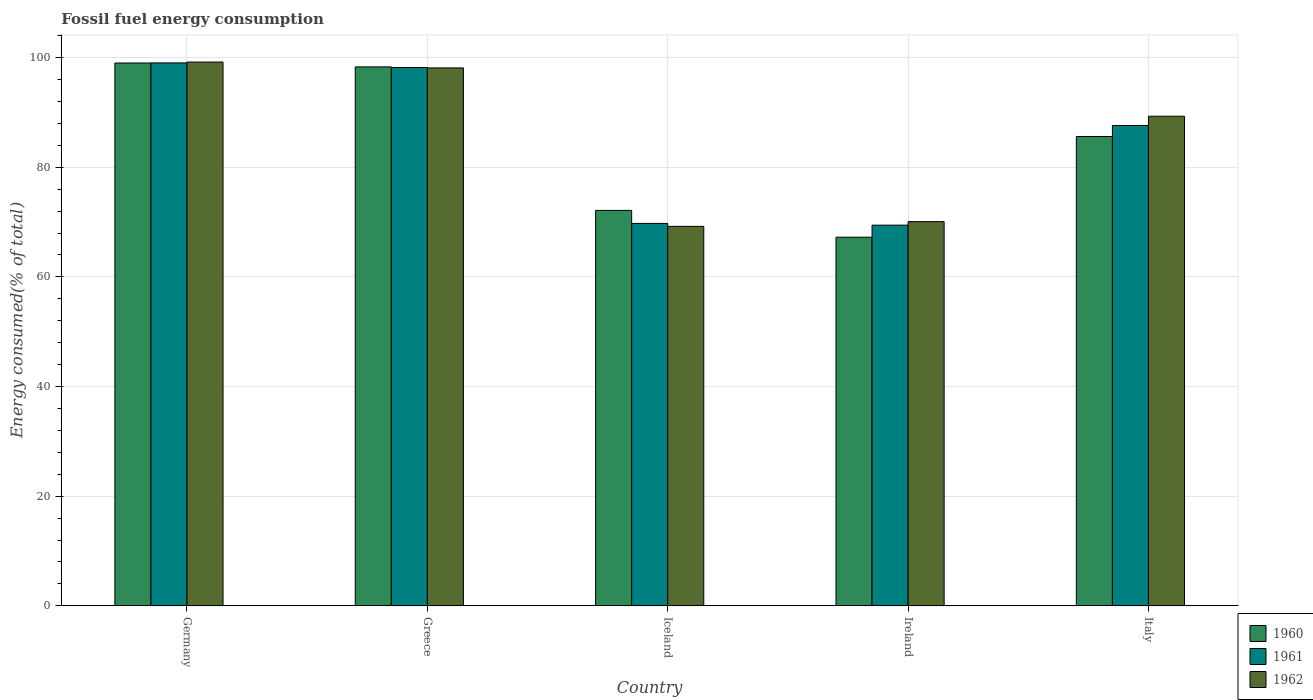How many different coloured bars are there?
Provide a succinct answer. 3. How many groups of bars are there?
Provide a short and direct response. 5. Are the number of bars per tick equal to the number of legend labels?
Ensure brevity in your answer.  Yes. What is the label of the 4th group of bars from the left?
Provide a succinct answer. Ireland. What is the percentage of energy consumed in 1962 in Iceland?
Make the answer very short. 69.22. Across all countries, what is the maximum percentage of energy consumed in 1962?
Your response must be concise. 99.19. Across all countries, what is the minimum percentage of energy consumed in 1961?
Ensure brevity in your answer.  69.44. In which country was the percentage of energy consumed in 1962 maximum?
Your answer should be compact. Germany. In which country was the percentage of energy consumed in 1961 minimum?
Make the answer very short. Ireland. What is the total percentage of energy consumed in 1962 in the graph?
Your answer should be compact. 425.93. What is the difference between the percentage of energy consumed in 1960 in Greece and that in Ireland?
Keep it short and to the point. 31.07. What is the difference between the percentage of energy consumed in 1961 in Greece and the percentage of energy consumed in 1960 in Ireland?
Your response must be concise. 30.96. What is the average percentage of energy consumed in 1961 per country?
Keep it short and to the point. 84.81. What is the difference between the percentage of energy consumed of/in 1961 and percentage of energy consumed of/in 1960 in Greece?
Give a very brief answer. -0.11. What is the ratio of the percentage of energy consumed in 1960 in Greece to that in Iceland?
Your response must be concise. 1.36. Is the percentage of energy consumed in 1961 in Iceland less than that in Ireland?
Your response must be concise. No. What is the difference between the highest and the second highest percentage of energy consumed in 1961?
Offer a very short reply. -0.84. What is the difference between the highest and the lowest percentage of energy consumed in 1962?
Offer a terse response. 29.98. What does the 1st bar from the left in Germany represents?
Make the answer very short. 1960. What does the 2nd bar from the right in Iceland represents?
Your answer should be compact. 1961. How many bars are there?
Your response must be concise. 15. Are all the bars in the graph horizontal?
Your answer should be compact. No. Are the values on the major ticks of Y-axis written in scientific E-notation?
Keep it short and to the point. No. Does the graph contain any zero values?
Provide a short and direct response. No. Where does the legend appear in the graph?
Give a very brief answer. Bottom right. How many legend labels are there?
Your response must be concise. 3. What is the title of the graph?
Provide a succinct answer. Fossil fuel energy consumption. Does "1963" appear as one of the legend labels in the graph?
Keep it short and to the point. No. What is the label or title of the X-axis?
Give a very brief answer. Country. What is the label or title of the Y-axis?
Ensure brevity in your answer.  Energy consumed(% of total). What is the Energy consumed(% of total) in 1960 in Germany?
Your response must be concise. 99.02. What is the Energy consumed(% of total) in 1961 in Germany?
Your answer should be very brief. 99.04. What is the Energy consumed(% of total) in 1962 in Germany?
Your response must be concise. 99.19. What is the Energy consumed(% of total) of 1960 in Greece?
Your answer should be compact. 98.31. What is the Energy consumed(% of total) of 1961 in Greece?
Keep it short and to the point. 98.2. What is the Energy consumed(% of total) of 1962 in Greece?
Provide a short and direct response. 98.12. What is the Energy consumed(% of total) of 1960 in Iceland?
Provide a short and direct response. 72.13. What is the Energy consumed(% of total) of 1961 in Iceland?
Your answer should be compact. 69.76. What is the Energy consumed(% of total) in 1962 in Iceland?
Offer a very short reply. 69.22. What is the Energy consumed(% of total) of 1960 in Ireland?
Provide a short and direct response. 67.24. What is the Energy consumed(% of total) in 1961 in Ireland?
Give a very brief answer. 69.44. What is the Energy consumed(% of total) of 1962 in Ireland?
Make the answer very short. 70.09. What is the Energy consumed(% of total) of 1960 in Italy?
Your answer should be compact. 85.61. What is the Energy consumed(% of total) in 1961 in Italy?
Give a very brief answer. 87.62. What is the Energy consumed(% of total) in 1962 in Italy?
Keep it short and to the point. 89.31. Across all countries, what is the maximum Energy consumed(% of total) in 1960?
Your response must be concise. 99.02. Across all countries, what is the maximum Energy consumed(% of total) in 1961?
Offer a very short reply. 99.04. Across all countries, what is the maximum Energy consumed(% of total) in 1962?
Ensure brevity in your answer.  99.19. Across all countries, what is the minimum Energy consumed(% of total) in 1960?
Give a very brief answer. 67.24. Across all countries, what is the minimum Energy consumed(% of total) of 1961?
Make the answer very short. 69.44. Across all countries, what is the minimum Energy consumed(% of total) of 1962?
Your answer should be compact. 69.22. What is the total Energy consumed(% of total) in 1960 in the graph?
Make the answer very short. 422.31. What is the total Energy consumed(% of total) in 1961 in the graph?
Provide a short and direct response. 424.05. What is the total Energy consumed(% of total) of 1962 in the graph?
Offer a terse response. 425.93. What is the difference between the Energy consumed(% of total) in 1960 in Germany and that in Greece?
Offer a terse response. 0.71. What is the difference between the Energy consumed(% of total) of 1961 in Germany and that in Greece?
Ensure brevity in your answer.  0.84. What is the difference between the Energy consumed(% of total) of 1962 in Germany and that in Greece?
Make the answer very short. 1.07. What is the difference between the Energy consumed(% of total) of 1960 in Germany and that in Iceland?
Ensure brevity in your answer.  26.89. What is the difference between the Energy consumed(% of total) of 1961 in Germany and that in Iceland?
Give a very brief answer. 29.28. What is the difference between the Energy consumed(% of total) of 1962 in Germany and that in Iceland?
Give a very brief answer. 29.98. What is the difference between the Energy consumed(% of total) in 1960 in Germany and that in Ireland?
Give a very brief answer. 31.78. What is the difference between the Energy consumed(% of total) of 1961 in Germany and that in Ireland?
Your response must be concise. 29.6. What is the difference between the Energy consumed(% of total) in 1962 in Germany and that in Ireland?
Your answer should be compact. 29.11. What is the difference between the Energy consumed(% of total) in 1960 in Germany and that in Italy?
Provide a short and direct response. 13.41. What is the difference between the Energy consumed(% of total) in 1961 in Germany and that in Italy?
Give a very brief answer. 11.42. What is the difference between the Energy consumed(% of total) in 1962 in Germany and that in Italy?
Make the answer very short. 9.88. What is the difference between the Energy consumed(% of total) in 1960 in Greece and that in Iceland?
Your answer should be very brief. 26.18. What is the difference between the Energy consumed(% of total) in 1961 in Greece and that in Iceland?
Offer a very short reply. 28.44. What is the difference between the Energy consumed(% of total) of 1962 in Greece and that in Iceland?
Your answer should be very brief. 28.91. What is the difference between the Energy consumed(% of total) in 1960 in Greece and that in Ireland?
Ensure brevity in your answer.  31.07. What is the difference between the Energy consumed(% of total) of 1961 in Greece and that in Ireland?
Provide a succinct answer. 28.76. What is the difference between the Energy consumed(% of total) in 1962 in Greece and that in Ireland?
Make the answer very short. 28.04. What is the difference between the Energy consumed(% of total) of 1960 in Greece and that in Italy?
Make the answer very short. 12.7. What is the difference between the Energy consumed(% of total) in 1961 in Greece and that in Italy?
Your response must be concise. 10.58. What is the difference between the Energy consumed(% of total) in 1962 in Greece and that in Italy?
Offer a terse response. 8.81. What is the difference between the Energy consumed(% of total) in 1960 in Iceland and that in Ireland?
Ensure brevity in your answer.  4.89. What is the difference between the Energy consumed(% of total) of 1961 in Iceland and that in Ireland?
Offer a terse response. 0.32. What is the difference between the Energy consumed(% of total) in 1962 in Iceland and that in Ireland?
Give a very brief answer. -0.87. What is the difference between the Energy consumed(% of total) in 1960 in Iceland and that in Italy?
Make the answer very short. -13.48. What is the difference between the Energy consumed(% of total) in 1961 in Iceland and that in Italy?
Provide a short and direct response. -17.86. What is the difference between the Energy consumed(% of total) of 1962 in Iceland and that in Italy?
Offer a terse response. -20.09. What is the difference between the Energy consumed(% of total) in 1960 in Ireland and that in Italy?
Offer a very short reply. -18.37. What is the difference between the Energy consumed(% of total) of 1961 in Ireland and that in Italy?
Provide a succinct answer. -18.18. What is the difference between the Energy consumed(% of total) in 1962 in Ireland and that in Italy?
Your response must be concise. -19.23. What is the difference between the Energy consumed(% of total) in 1960 in Germany and the Energy consumed(% of total) in 1961 in Greece?
Ensure brevity in your answer.  0.82. What is the difference between the Energy consumed(% of total) of 1960 in Germany and the Energy consumed(% of total) of 1962 in Greece?
Offer a very short reply. 0.9. What is the difference between the Energy consumed(% of total) in 1961 in Germany and the Energy consumed(% of total) in 1962 in Greece?
Provide a short and direct response. 0.92. What is the difference between the Energy consumed(% of total) of 1960 in Germany and the Energy consumed(% of total) of 1961 in Iceland?
Your response must be concise. 29.26. What is the difference between the Energy consumed(% of total) in 1960 in Germany and the Energy consumed(% of total) in 1962 in Iceland?
Offer a terse response. 29.8. What is the difference between the Energy consumed(% of total) in 1961 in Germany and the Energy consumed(% of total) in 1962 in Iceland?
Provide a succinct answer. 29.82. What is the difference between the Energy consumed(% of total) in 1960 in Germany and the Energy consumed(% of total) in 1961 in Ireland?
Make the answer very short. 29.58. What is the difference between the Energy consumed(% of total) in 1960 in Germany and the Energy consumed(% of total) in 1962 in Ireland?
Ensure brevity in your answer.  28.93. What is the difference between the Energy consumed(% of total) of 1961 in Germany and the Energy consumed(% of total) of 1962 in Ireland?
Provide a short and direct response. 28.96. What is the difference between the Energy consumed(% of total) of 1960 in Germany and the Energy consumed(% of total) of 1961 in Italy?
Keep it short and to the point. 11.4. What is the difference between the Energy consumed(% of total) in 1960 in Germany and the Energy consumed(% of total) in 1962 in Italy?
Your response must be concise. 9.71. What is the difference between the Energy consumed(% of total) in 1961 in Germany and the Energy consumed(% of total) in 1962 in Italy?
Offer a very short reply. 9.73. What is the difference between the Energy consumed(% of total) of 1960 in Greece and the Energy consumed(% of total) of 1961 in Iceland?
Ensure brevity in your answer.  28.55. What is the difference between the Energy consumed(% of total) of 1960 in Greece and the Energy consumed(% of total) of 1962 in Iceland?
Your answer should be very brief. 29.09. What is the difference between the Energy consumed(% of total) in 1961 in Greece and the Energy consumed(% of total) in 1962 in Iceland?
Provide a short and direct response. 28.98. What is the difference between the Energy consumed(% of total) of 1960 in Greece and the Energy consumed(% of total) of 1961 in Ireland?
Provide a succinct answer. 28.87. What is the difference between the Energy consumed(% of total) of 1960 in Greece and the Energy consumed(% of total) of 1962 in Ireland?
Your answer should be compact. 28.23. What is the difference between the Energy consumed(% of total) of 1961 in Greece and the Energy consumed(% of total) of 1962 in Ireland?
Ensure brevity in your answer.  28.11. What is the difference between the Energy consumed(% of total) in 1960 in Greece and the Energy consumed(% of total) in 1961 in Italy?
Your response must be concise. 10.69. What is the difference between the Energy consumed(% of total) of 1960 in Greece and the Energy consumed(% of total) of 1962 in Italy?
Your answer should be very brief. 9. What is the difference between the Energy consumed(% of total) in 1961 in Greece and the Energy consumed(% of total) in 1962 in Italy?
Offer a terse response. 8.89. What is the difference between the Energy consumed(% of total) of 1960 in Iceland and the Energy consumed(% of total) of 1961 in Ireland?
Make the answer very short. 2.69. What is the difference between the Energy consumed(% of total) in 1960 in Iceland and the Energy consumed(% of total) in 1962 in Ireland?
Offer a very short reply. 2.04. What is the difference between the Energy consumed(% of total) in 1961 in Iceland and the Energy consumed(% of total) in 1962 in Ireland?
Make the answer very short. -0.33. What is the difference between the Energy consumed(% of total) of 1960 in Iceland and the Energy consumed(% of total) of 1961 in Italy?
Offer a terse response. -15.49. What is the difference between the Energy consumed(% of total) in 1960 in Iceland and the Energy consumed(% of total) in 1962 in Italy?
Your response must be concise. -17.18. What is the difference between the Energy consumed(% of total) of 1961 in Iceland and the Energy consumed(% of total) of 1962 in Italy?
Offer a terse response. -19.55. What is the difference between the Energy consumed(% of total) in 1960 in Ireland and the Energy consumed(% of total) in 1961 in Italy?
Your response must be concise. -20.38. What is the difference between the Energy consumed(% of total) in 1960 in Ireland and the Energy consumed(% of total) in 1962 in Italy?
Your answer should be compact. -22.07. What is the difference between the Energy consumed(% of total) in 1961 in Ireland and the Energy consumed(% of total) in 1962 in Italy?
Ensure brevity in your answer.  -19.87. What is the average Energy consumed(% of total) in 1960 per country?
Provide a succinct answer. 84.46. What is the average Energy consumed(% of total) in 1961 per country?
Make the answer very short. 84.81. What is the average Energy consumed(% of total) in 1962 per country?
Make the answer very short. 85.19. What is the difference between the Energy consumed(% of total) of 1960 and Energy consumed(% of total) of 1961 in Germany?
Offer a terse response. -0.02. What is the difference between the Energy consumed(% of total) of 1960 and Energy consumed(% of total) of 1962 in Germany?
Provide a succinct answer. -0.17. What is the difference between the Energy consumed(% of total) in 1961 and Energy consumed(% of total) in 1962 in Germany?
Offer a terse response. -0.15. What is the difference between the Energy consumed(% of total) in 1960 and Energy consumed(% of total) in 1961 in Greece?
Keep it short and to the point. 0.11. What is the difference between the Energy consumed(% of total) in 1960 and Energy consumed(% of total) in 1962 in Greece?
Make the answer very short. 0.19. What is the difference between the Energy consumed(% of total) in 1961 and Energy consumed(% of total) in 1962 in Greece?
Keep it short and to the point. 0.07. What is the difference between the Energy consumed(% of total) of 1960 and Energy consumed(% of total) of 1961 in Iceland?
Make the answer very short. 2.37. What is the difference between the Energy consumed(% of total) in 1960 and Energy consumed(% of total) in 1962 in Iceland?
Your answer should be compact. 2.91. What is the difference between the Energy consumed(% of total) of 1961 and Energy consumed(% of total) of 1962 in Iceland?
Offer a very short reply. 0.54. What is the difference between the Energy consumed(% of total) of 1960 and Energy consumed(% of total) of 1961 in Ireland?
Make the answer very short. -2.2. What is the difference between the Energy consumed(% of total) in 1960 and Energy consumed(% of total) in 1962 in Ireland?
Give a very brief answer. -2.84. What is the difference between the Energy consumed(% of total) of 1961 and Energy consumed(% of total) of 1962 in Ireland?
Give a very brief answer. -0.65. What is the difference between the Energy consumed(% of total) in 1960 and Energy consumed(% of total) in 1961 in Italy?
Your answer should be compact. -2.01. What is the difference between the Energy consumed(% of total) of 1960 and Energy consumed(% of total) of 1962 in Italy?
Your answer should be very brief. -3.7. What is the difference between the Energy consumed(% of total) of 1961 and Energy consumed(% of total) of 1962 in Italy?
Offer a terse response. -1.69. What is the ratio of the Energy consumed(% of total) in 1961 in Germany to that in Greece?
Ensure brevity in your answer.  1.01. What is the ratio of the Energy consumed(% of total) of 1962 in Germany to that in Greece?
Offer a terse response. 1.01. What is the ratio of the Energy consumed(% of total) in 1960 in Germany to that in Iceland?
Your answer should be compact. 1.37. What is the ratio of the Energy consumed(% of total) in 1961 in Germany to that in Iceland?
Provide a succinct answer. 1.42. What is the ratio of the Energy consumed(% of total) in 1962 in Germany to that in Iceland?
Your response must be concise. 1.43. What is the ratio of the Energy consumed(% of total) in 1960 in Germany to that in Ireland?
Your answer should be compact. 1.47. What is the ratio of the Energy consumed(% of total) of 1961 in Germany to that in Ireland?
Your answer should be compact. 1.43. What is the ratio of the Energy consumed(% of total) of 1962 in Germany to that in Ireland?
Your answer should be compact. 1.42. What is the ratio of the Energy consumed(% of total) in 1960 in Germany to that in Italy?
Give a very brief answer. 1.16. What is the ratio of the Energy consumed(% of total) of 1961 in Germany to that in Italy?
Give a very brief answer. 1.13. What is the ratio of the Energy consumed(% of total) of 1962 in Germany to that in Italy?
Offer a terse response. 1.11. What is the ratio of the Energy consumed(% of total) of 1960 in Greece to that in Iceland?
Give a very brief answer. 1.36. What is the ratio of the Energy consumed(% of total) of 1961 in Greece to that in Iceland?
Your response must be concise. 1.41. What is the ratio of the Energy consumed(% of total) in 1962 in Greece to that in Iceland?
Provide a short and direct response. 1.42. What is the ratio of the Energy consumed(% of total) in 1960 in Greece to that in Ireland?
Your answer should be compact. 1.46. What is the ratio of the Energy consumed(% of total) of 1961 in Greece to that in Ireland?
Ensure brevity in your answer.  1.41. What is the ratio of the Energy consumed(% of total) in 1962 in Greece to that in Ireland?
Provide a succinct answer. 1.4. What is the ratio of the Energy consumed(% of total) in 1960 in Greece to that in Italy?
Keep it short and to the point. 1.15. What is the ratio of the Energy consumed(% of total) of 1961 in Greece to that in Italy?
Offer a terse response. 1.12. What is the ratio of the Energy consumed(% of total) in 1962 in Greece to that in Italy?
Give a very brief answer. 1.1. What is the ratio of the Energy consumed(% of total) of 1960 in Iceland to that in Ireland?
Make the answer very short. 1.07. What is the ratio of the Energy consumed(% of total) of 1962 in Iceland to that in Ireland?
Your answer should be very brief. 0.99. What is the ratio of the Energy consumed(% of total) of 1960 in Iceland to that in Italy?
Provide a succinct answer. 0.84. What is the ratio of the Energy consumed(% of total) of 1961 in Iceland to that in Italy?
Offer a very short reply. 0.8. What is the ratio of the Energy consumed(% of total) in 1962 in Iceland to that in Italy?
Provide a short and direct response. 0.78. What is the ratio of the Energy consumed(% of total) in 1960 in Ireland to that in Italy?
Offer a very short reply. 0.79. What is the ratio of the Energy consumed(% of total) in 1961 in Ireland to that in Italy?
Make the answer very short. 0.79. What is the ratio of the Energy consumed(% of total) of 1962 in Ireland to that in Italy?
Offer a terse response. 0.78. What is the difference between the highest and the second highest Energy consumed(% of total) in 1960?
Your answer should be compact. 0.71. What is the difference between the highest and the second highest Energy consumed(% of total) in 1961?
Provide a succinct answer. 0.84. What is the difference between the highest and the second highest Energy consumed(% of total) in 1962?
Provide a short and direct response. 1.07. What is the difference between the highest and the lowest Energy consumed(% of total) in 1960?
Your response must be concise. 31.78. What is the difference between the highest and the lowest Energy consumed(% of total) of 1961?
Offer a very short reply. 29.6. What is the difference between the highest and the lowest Energy consumed(% of total) of 1962?
Your response must be concise. 29.98. 